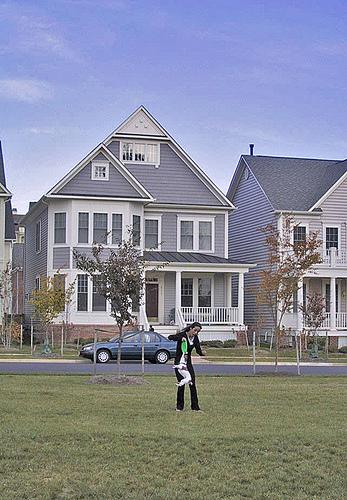How is the dog in midair? biting frisbee 